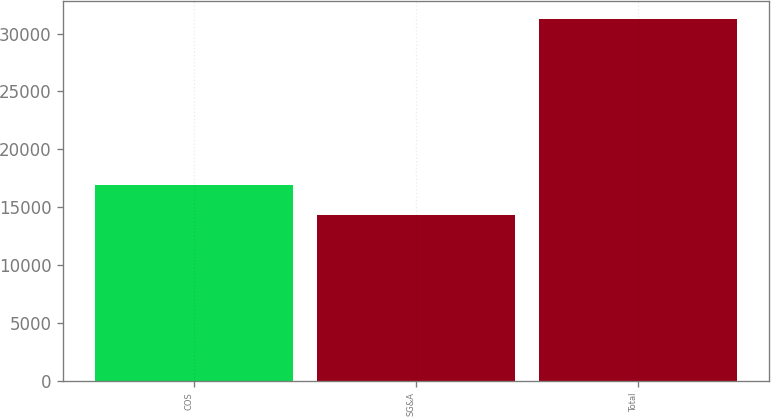Convert chart. <chart><loc_0><loc_0><loc_500><loc_500><bar_chart><fcel>COS<fcel>SG&A<fcel>Total<nl><fcel>16893<fcel>14328<fcel>31221<nl></chart> 